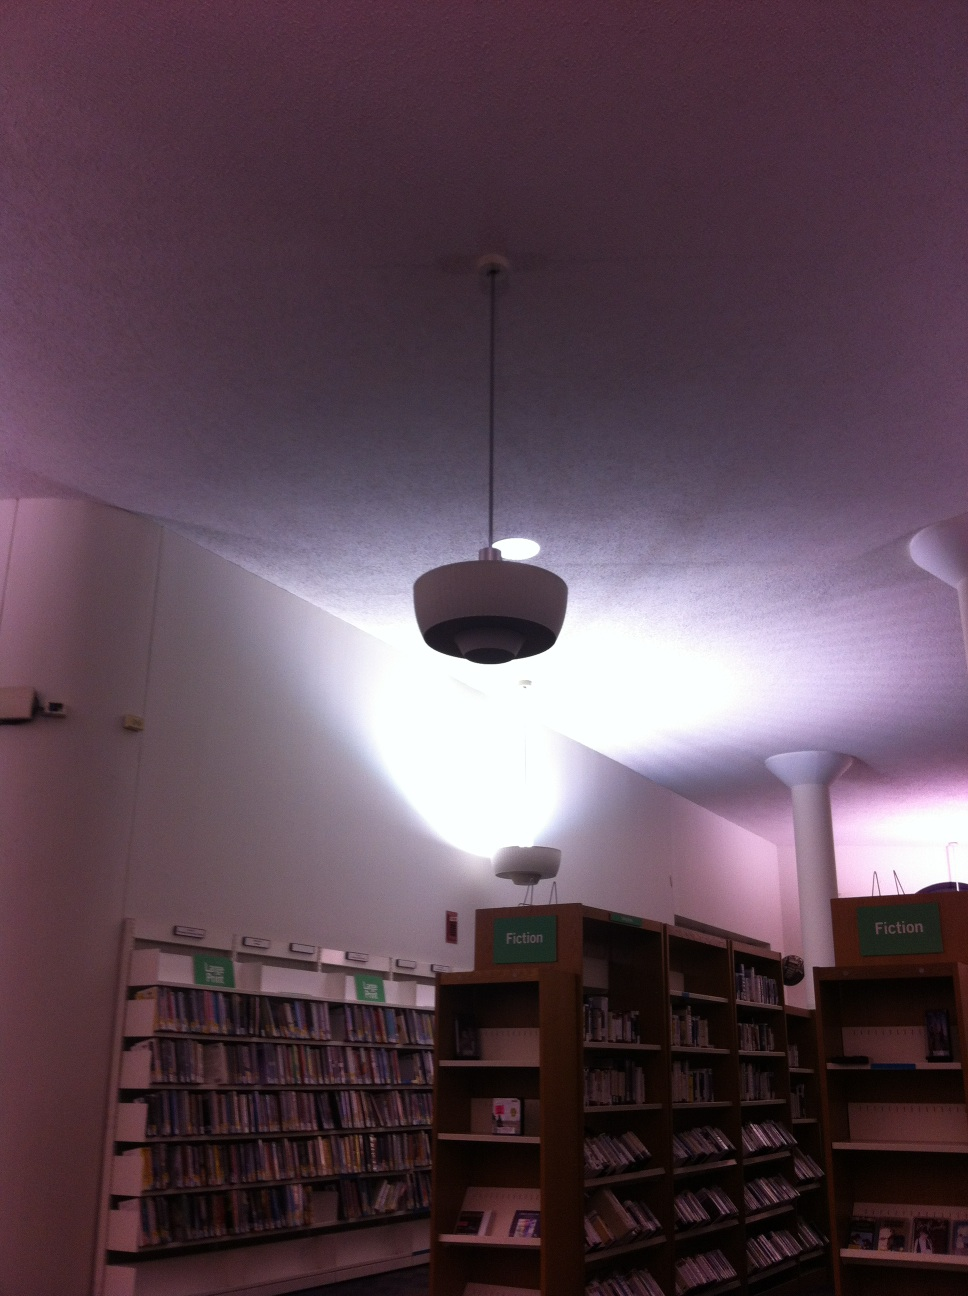Imagine this place was a portal to a fantasy world. What kind of world would it be? Imagine stepping into this library and suddenly finding yourself in a fantastical world, where each bookshelf is a gateway to different realms. One shelf might lead you to an enchanted forest filled with talking animals and magical creatures. Another might whisk you away to a futuristic city with flying cars and advanced technology. The adventures are endless, and each book offers a new portal to explore! 